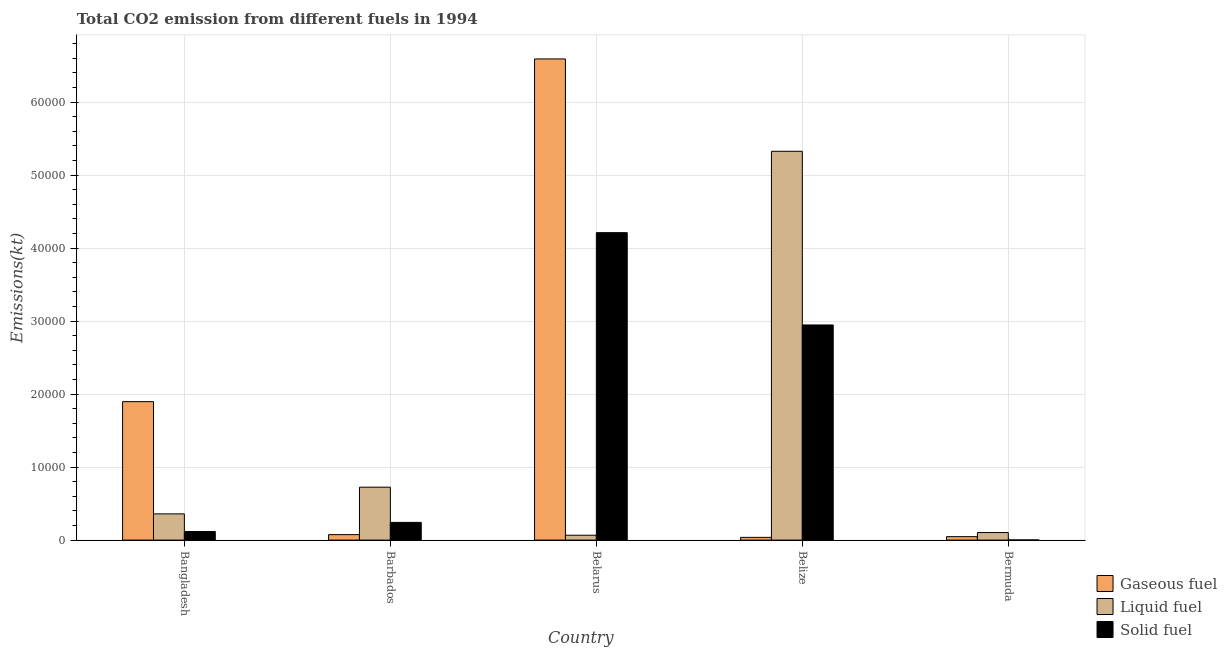How many groups of bars are there?
Provide a succinct answer. 5. Are the number of bars on each tick of the X-axis equal?
Ensure brevity in your answer.  Yes. How many bars are there on the 3rd tick from the right?
Keep it short and to the point. 3. What is the label of the 1st group of bars from the left?
Provide a succinct answer. Bangladesh. What is the amount of co2 emissions from liquid fuel in Barbados?
Give a very brief answer. 7249.66. Across all countries, what is the maximum amount of co2 emissions from solid fuel?
Your response must be concise. 4.21e+04. Across all countries, what is the minimum amount of co2 emissions from liquid fuel?
Make the answer very short. 667.39. In which country was the amount of co2 emissions from gaseous fuel maximum?
Your answer should be very brief. Belarus. In which country was the amount of co2 emissions from solid fuel minimum?
Give a very brief answer. Bermuda. What is the total amount of co2 emissions from gaseous fuel in the graph?
Provide a short and direct response. 8.65e+04. What is the difference between the amount of co2 emissions from solid fuel in Belarus and that in Bermuda?
Provide a short and direct response. 4.21e+04. What is the difference between the amount of co2 emissions from liquid fuel in Bermuda and the amount of co2 emissions from gaseous fuel in Barbados?
Keep it short and to the point. 286.03. What is the average amount of co2 emissions from liquid fuel per country?
Your answer should be compact. 1.32e+04. What is the difference between the amount of co2 emissions from liquid fuel and amount of co2 emissions from gaseous fuel in Bermuda?
Make the answer very short. 561.05. In how many countries, is the amount of co2 emissions from solid fuel greater than 66000 kt?
Give a very brief answer. 0. What is the ratio of the amount of co2 emissions from liquid fuel in Barbados to that in Belize?
Your answer should be very brief. 0.14. Is the difference between the amount of co2 emissions from solid fuel in Bangladesh and Belize greater than the difference between the amount of co2 emissions from gaseous fuel in Bangladesh and Belize?
Provide a short and direct response. No. What is the difference between the highest and the second highest amount of co2 emissions from solid fuel?
Ensure brevity in your answer.  1.26e+04. What is the difference between the highest and the lowest amount of co2 emissions from gaseous fuel?
Offer a terse response. 6.55e+04. Is the sum of the amount of co2 emissions from gaseous fuel in Bangladesh and Belize greater than the maximum amount of co2 emissions from solid fuel across all countries?
Ensure brevity in your answer.  No. What does the 2nd bar from the left in Belize represents?
Give a very brief answer. Liquid fuel. What does the 1st bar from the right in Belarus represents?
Offer a terse response. Solid fuel. Is it the case that in every country, the sum of the amount of co2 emissions from gaseous fuel and amount of co2 emissions from liquid fuel is greater than the amount of co2 emissions from solid fuel?
Offer a terse response. Yes. Are all the bars in the graph horizontal?
Provide a succinct answer. No. How many countries are there in the graph?
Your answer should be very brief. 5. Does the graph contain any zero values?
Your answer should be compact. No. Does the graph contain grids?
Provide a succinct answer. Yes. Where does the legend appear in the graph?
Provide a short and direct response. Bottom right. How are the legend labels stacked?
Offer a terse response. Vertical. What is the title of the graph?
Your response must be concise. Total CO2 emission from different fuels in 1994. Does "Ores and metals" appear as one of the legend labels in the graph?
Offer a very short reply. No. What is the label or title of the X-axis?
Your answer should be very brief. Country. What is the label or title of the Y-axis?
Provide a succinct answer. Emissions(kt). What is the Emissions(kt) in Gaseous fuel in Bangladesh?
Your answer should be very brief. 1.90e+04. What is the Emissions(kt) of Liquid fuel in Bangladesh?
Your answer should be very brief. 3593.66. What is the Emissions(kt) of Solid fuel in Bangladesh?
Provide a short and direct response. 1177.11. What is the Emissions(kt) in Gaseous fuel in Barbados?
Your answer should be very brief. 748.07. What is the Emissions(kt) of Liquid fuel in Barbados?
Your answer should be very brief. 7249.66. What is the Emissions(kt) in Solid fuel in Barbados?
Keep it short and to the point. 2427.55. What is the Emissions(kt) in Gaseous fuel in Belarus?
Offer a terse response. 6.59e+04. What is the Emissions(kt) of Liquid fuel in Belarus?
Offer a terse response. 667.39. What is the Emissions(kt) in Solid fuel in Belarus?
Your answer should be very brief. 4.21e+04. What is the Emissions(kt) in Gaseous fuel in Belize?
Provide a short and direct response. 374.03. What is the Emissions(kt) of Liquid fuel in Belize?
Your response must be concise. 5.33e+04. What is the Emissions(kt) in Solid fuel in Belize?
Your answer should be very brief. 2.95e+04. What is the Emissions(kt) in Gaseous fuel in Bermuda?
Ensure brevity in your answer.  473.04. What is the Emissions(kt) of Liquid fuel in Bermuda?
Offer a terse response. 1034.09. What is the Emissions(kt) in Solid fuel in Bermuda?
Offer a terse response. 18.34. Across all countries, what is the maximum Emissions(kt) in Gaseous fuel?
Provide a short and direct response. 6.59e+04. Across all countries, what is the maximum Emissions(kt) of Liquid fuel?
Your answer should be compact. 5.33e+04. Across all countries, what is the maximum Emissions(kt) in Solid fuel?
Your response must be concise. 4.21e+04. Across all countries, what is the minimum Emissions(kt) in Gaseous fuel?
Offer a terse response. 374.03. Across all countries, what is the minimum Emissions(kt) in Liquid fuel?
Your response must be concise. 667.39. Across all countries, what is the minimum Emissions(kt) in Solid fuel?
Provide a succinct answer. 18.34. What is the total Emissions(kt) in Gaseous fuel in the graph?
Give a very brief answer. 8.65e+04. What is the total Emissions(kt) of Liquid fuel in the graph?
Offer a terse response. 6.58e+04. What is the total Emissions(kt) of Solid fuel in the graph?
Offer a terse response. 7.52e+04. What is the difference between the Emissions(kt) in Gaseous fuel in Bangladesh and that in Barbados?
Your answer should be compact. 1.82e+04. What is the difference between the Emissions(kt) in Liquid fuel in Bangladesh and that in Barbados?
Keep it short and to the point. -3656. What is the difference between the Emissions(kt) of Solid fuel in Bangladesh and that in Barbados?
Provide a short and direct response. -1250.45. What is the difference between the Emissions(kt) in Gaseous fuel in Bangladesh and that in Belarus?
Provide a short and direct response. -4.69e+04. What is the difference between the Emissions(kt) in Liquid fuel in Bangladesh and that in Belarus?
Provide a short and direct response. 2926.27. What is the difference between the Emissions(kt) in Solid fuel in Bangladesh and that in Belarus?
Keep it short and to the point. -4.09e+04. What is the difference between the Emissions(kt) in Gaseous fuel in Bangladesh and that in Belize?
Provide a short and direct response. 1.86e+04. What is the difference between the Emissions(kt) of Liquid fuel in Bangladesh and that in Belize?
Your answer should be very brief. -4.97e+04. What is the difference between the Emissions(kt) in Solid fuel in Bangladesh and that in Belize?
Give a very brief answer. -2.83e+04. What is the difference between the Emissions(kt) of Gaseous fuel in Bangladesh and that in Bermuda?
Your answer should be very brief. 1.85e+04. What is the difference between the Emissions(kt) of Liquid fuel in Bangladesh and that in Bermuda?
Offer a very short reply. 2559.57. What is the difference between the Emissions(kt) of Solid fuel in Bangladesh and that in Bermuda?
Your answer should be compact. 1158.77. What is the difference between the Emissions(kt) of Gaseous fuel in Barbados and that in Belarus?
Give a very brief answer. -6.52e+04. What is the difference between the Emissions(kt) in Liquid fuel in Barbados and that in Belarus?
Your answer should be compact. 6582.27. What is the difference between the Emissions(kt) in Solid fuel in Barbados and that in Belarus?
Keep it short and to the point. -3.97e+04. What is the difference between the Emissions(kt) in Gaseous fuel in Barbados and that in Belize?
Keep it short and to the point. 374.03. What is the difference between the Emissions(kt) of Liquid fuel in Barbados and that in Belize?
Your answer should be very brief. -4.60e+04. What is the difference between the Emissions(kt) of Solid fuel in Barbados and that in Belize?
Your answer should be very brief. -2.70e+04. What is the difference between the Emissions(kt) in Gaseous fuel in Barbados and that in Bermuda?
Provide a short and direct response. 275.02. What is the difference between the Emissions(kt) of Liquid fuel in Barbados and that in Bermuda?
Offer a terse response. 6215.56. What is the difference between the Emissions(kt) in Solid fuel in Barbados and that in Bermuda?
Your response must be concise. 2409.22. What is the difference between the Emissions(kt) of Gaseous fuel in Belarus and that in Belize?
Provide a short and direct response. 6.55e+04. What is the difference between the Emissions(kt) in Liquid fuel in Belarus and that in Belize?
Keep it short and to the point. -5.26e+04. What is the difference between the Emissions(kt) of Solid fuel in Belarus and that in Belize?
Keep it short and to the point. 1.26e+04. What is the difference between the Emissions(kt) of Gaseous fuel in Belarus and that in Bermuda?
Your response must be concise. 6.54e+04. What is the difference between the Emissions(kt) in Liquid fuel in Belarus and that in Bermuda?
Provide a succinct answer. -366.7. What is the difference between the Emissions(kt) in Solid fuel in Belarus and that in Bermuda?
Provide a short and direct response. 4.21e+04. What is the difference between the Emissions(kt) of Gaseous fuel in Belize and that in Bermuda?
Offer a terse response. -99.01. What is the difference between the Emissions(kt) in Liquid fuel in Belize and that in Bermuda?
Ensure brevity in your answer.  5.22e+04. What is the difference between the Emissions(kt) of Solid fuel in Belize and that in Bermuda?
Provide a succinct answer. 2.95e+04. What is the difference between the Emissions(kt) in Gaseous fuel in Bangladesh and the Emissions(kt) in Liquid fuel in Barbados?
Your answer should be very brief. 1.17e+04. What is the difference between the Emissions(kt) of Gaseous fuel in Bangladesh and the Emissions(kt) of Solid fuel in Barbados?
Your response must be concise. 1.65e+04. What is the difference between the Emissions(kt) of Liquid fuel in Bangladesh and the Emissions(kt) of Solid fuel in Barbados?
Offer a very short reply. 1166.11. What is the difference between the Emissions(kt) in Gaseous fuel in Bangladesh and the Emissions(kt) in Liquid fuel in Belarus?
Make the answer very short. 1.83e+04. What is the difference between the Emissions(kt) of Gaseous fuel in Bangladesh and the Emissions(kt) of Solid fuel in Belarus?
Make the answer very short. -2.31e+04. What is the difference between the Emissions(kt) of Liquid fuel in Bangladesh and the Emissions(kt) of Solid fuel in Belarus?
Keep it short and to the point. -3.85e+04. What is the difference between the Emissions(kt) of Gaseous fuel in Bangladesh and the Emissions(kt) of Liquid fuel in Belize?
Offer a terse response. -3.43e+04. What is the difference between the Emissions(kt) of Gaseous fuel in Bangladesh and the Emissions(kt) of Solid fuel in Belize?
Give a very brief answer. -1.05e+04. What is the difference between the Emissions(kt) in Liquid fuel in Bangladesh and the Emissions(kt) in Solid fuel in Belize?
Your answer should be compact. -2.59e+04. What is the difference between the Emissions(kt) in Gaseous fuel in Bangladesh and the Emissions(kt) in Liquid fuel in Bermuda?
Your response must be concise. 1.79e+04. What is the difference between the Emissions(kt) in Gaseous fuel in Bangladesh and the Emissions(kt) in Solid fuel in Bermuda?
Your answer should be compact. 1.90e+04. What is the difference between the Emissions(kt) of Liquid fuel in Bangladesh and the Emissions(kt) of Solid fuel in Bermuda?
Make the answer very short. 3575.32. What is the difference between the Emissions(kt) of Gaseous fuel in Barbados and the Emissions(kt) of Liquid fuel in Belarus?
Provide a short and direct response. 80.67. What is the difference between the Emissions(kt) of Gaseous fuel in Barbados and the Emissions(kt) of Solid fuel in Belarus?
Your answer should be very brief. -4.14e+04. What is the difference between the Emissions(kt) in Liquid fuel in Barbados and the Emissions(kt) in Solid fuel in Belarus?
Your response must be concise. -3.49e+04. What is the difference between the Emissions(kt) in Gaseous fuel in Barbados and the Emissions(kt) in Liquid fuel in Belize?
Offer a very short reply. -5.25e+04. What is the difference between the Emissions(kt) of Gaseous fuel in Barbados and the Emissions(kt) of Solid fuel in Belize?
Keep it short and to the point. -2.87e+04. What is the difference between the Emissions(kt) in Liquid fuel in Barbados and the Emissions(kt) in Solid fuel in Belize?
Your answer should be compact. -2.22e+04. What is the difference between the Emissions(kt) of Gaseous fuel in Barbados and the Emissions(kt) of Liquid fuel in Bermuda?
Your answer should be very brief. -286.03. What is the difference between the Emissions(kt) of Gaseous fuel in Barbados and the Emissions(kt) of Solid fuel in Bermuda?
Offer a terse response. 729.73. What is the difference between the Emissions(kt) in Liquid fuel in Barbados and the Emissions(kt) in Solid fuel in Bermuda?
Ensure brevity in your answer.  7231.32. What is the difference between the Emissions(kt) in Gaseous fuel in Belarus and the Emissions(kt) in Liquid fuel in Belize?
Offer a terse response. 1.27e+04. What is the difference between the Emissions(kt) of Gaseous fuel in Belarus and the Emissions(kt) of Solid fuel in Belize?
Your response must be concise. 3.64e+04. What is the difference between the Emissions(kt) in Liquid fuel in Belarus and the Emissions(kt) in Solid fuel in Belize?
Provide a succinct answer. -2.88e+04. What is the difference between the Emissions(kt) of Gaseous fuel in Belarus and the Emissions(kt) of Liquid fuel in Bermuda?
Your response must be concise. 6.49e+04. What is the difference between the Emissions(kt) in Gaseous fuel in Belarus and the Emissions(kt) in Solid fuel in Bermuda?
Ensure brevity in your answer.  6.59e+04. What is the difference between the Emissions(kt) of Liquid fuel in Belarus and the Emissions(kt) of Solid fuel in Bermuda?
Your answer should be compact. 649.06. What is the difference between the Emissions(kt) in Gaseous fuel in Belize and the Emissions(kt) in Liquid fuel in Bermuda?
Ensure brevity in your answer.  -660.06. What is the difference between the Emissions(kt) of Gaseous fuel in Belize and the Emissions(kt) of Solid fuel in Bermuda?
Your response must be concise. 355.7. What is the difference between the Emissions(kt) in Liquid fuel in Belize and the Emissions(kt) in Solid fuel in Bermuda?
Give a very brief answer. 5.32e+04. What is the average Emissions(kt) in Gaseous fuel per country?
Your response must be concise. 1.73e+04. What is the average Emissions(kt) of Liquid fuel per country?
Provide a succinct answer. 1.32e+04. What is the average Emissions(kt) of Solid fuel per country?
Provide a succinct answer. 1.50e+04. What is the difference between the Emissions(kt) in Gaseous fuel and Emissions(kt) in Liquid fuel in Bangladesh?
Your answer should be compact. 1.54e+04. What is the difference between the Emissions(kt) in Gaseous fuel and Emissions(kt) in Solid fuel in Bangladesh?
Your answer should be very brief. 1.78e+04. What is the difference between the Emissions(kt) of Liquid fuel and Emissions(kt) of Solid fuel in Bangladesh?
Keep it short and to the point. 2416.55. What is the difference between the Emissions(kt) in Gaseous fuel and Emissions(kt) in Liquid fuel in Barbados?
Your response must be concise. -6501.59. What is the difference between the Emissions(kt) of Gaseous fuel and Emissions(kt) of Solid fuel in Barbados?
Offer a very short reply. -1679.49. What is the difference between the Emissions(kt) of Liquid fuel and Emissions(kt) of Solid fuel in Barbados?
Offer a terse response. 4822.1. What is the difference between the Emissions(kt) in Gaseous fuel and Emissions(kt) in Liquid fuel in Belarus?
Provide a succinct answer. 6.52e+04. What is the difference between the Emissions(kt) of Gaseous fuel and Emissions(kt) of Solid fuel in Belarus?
Give a very brief answer. 2.38e+04. What is the difference between the Emissions(kt) of Liquid fuel and Emissions(kt) of Solid fuel in Belarus?
Give a very brief answer. -4.14e+04. What is the difference between the Emissions(kt) of Gaseous fuel and Emissions(kt) of Liquid fuel in Belize?
Your answer should be compact. -5.29e+04. What is the difference between the Emissions(kt) of Gaseous fuel and Emissions(kt) of Solid fuel in Belize?
Give a very brief answer. -2.91e+04. What is the difference between the Emissions(kt) of Liquid fuel and Emissions(kt) of Solid fuel in Belize?
Your answer should be very brief. 2.38e+04. What is the difference between the Emissions(kt) in Gaseous fuel and Emissions(kt) in Liquid fuel in Bermuda?
Provide a succinct answer. -561.05. What is the difference between the Emissions(kt) in Gaseous fuel and Emissions(kt) in Solid fuel in Bermuda?
Ensure brevity in your answer.  454.71. What is the difference between the Emissions(kt) in Liquid fuel and Emissions(kt) in Solid fuel in Bermuda?
Keep it short and to the point. 1015.76. What is the ratio of the Emissions(kt) in Gaseous fuel in Bangladesh to that in Barbados?
Offer a terse response. 25.36. What is the ratio of the Emissions(kt) in Liquid fuel in Bangladesh to that in Barbados?
Ensure brevity in your answer.  0.5. What is the ratio of the Emissions(kt) in Solid fuel in Bangladesh to that in Barbados?
Your answer should be compact. 0.48. What is the ratio of the Emissions(kt) in Gaseous fuel in Bangladesh to that in Belarus?
Ensure brevity in your answer.  0.29. What is the ratio of the Emissions(kt) in Liquid fuel in Bangladesh to that in Belarus?
Give a very brief answer. 5.38. What is the ratio of the Emissions(kt) of Solid fuel in Bangladesh to that in Belarus?
Your answer should be compact. 0.03. What is the ratio of the Emissions(kt) in Gaseous fuel in Bangladesh to that in Belize?
Offer a terse response. 50.72. What is the ratio of the Emissions(kt) in Liquid fuel in Bangladesh to that in Belize?
Your answer should be compact. 0.07. What is the ratio of the Emissions(kt) in Solid fuel in Bangladesh to that in Belize?
Your answer should be very brief. 0.04. What is the ratio of the Emissions(kt) of Gaseous fuel in Bangladesh to that in Bermuda?
Make the answer very short. 40.1. What is the ratio of the Emissions(kt) in Liquid fuel in Bangladesh to that in Bermuda?
Offer a very short reply. 3.48. What is the ratio of the Emissions(kt) of Solid fuel in Bangladesh to that in Bermuda?
Offer a very short reply. 64.2. What is the ratio of the Emissions(kt) of Gaseous fuel in Barbados to that in Belarus?
Offer a terse response. 0.01. What is the ratio of the Emissions(kt) in Liquid fuel in Barbados to that in Belarus?
Ensure brevity in your answer.  10.86. What is the ratio of the Emissions(kt) of Solid fuel in Barbados to that in Belarus?
Provide a short and direct response. 0.06. What is the ratio of the Emissions(kt) of Gaseous fuel in Barbados to that in Belize?
Make the answer very short. 2. What is the ratio of the Emissions(kt) of Liquid fuel in Barbados to that in Belize?
Offer a very short reply. 0.14. What is the ratio of the Emissions(kt) of Solid fuel in Barbados to that in Belize?
Your answer should be very brief. 0.08. What is the ratio of the Emissions(kt) in Gaseous fuel in Barbados to that in Bermuda?
Provide a short and direct response. 1.58. What is the ratio of the Emissions(kt) of Liquid fuel in Barbados to that in Bermuda?
Keep it short and to the point. 7.01. What is the ratio of the Emissions(kt) of Solid fuel in Barbados to that in Bermuda?
Provide a short and direct response. 132.4. What is the ratio of the Emissions(kt) of Gaseous fuel in Belarus to that in Belize?
Provide a succinct answer. 176.23. What is the ratio of the Emissions(kt) of Liquid fuel in Belarus to that in Belize?
Your response must be concise. 0.01. What is the ratio of the Emissions(kt) of Solid fuel in Belarus to that in Belize?
Offer a very short reply. 1.43. What is the ratio of the Emissions(kt) in Gaseous fuel in Belarus to that in Bermuda?
Your answer should be very brief. 139.34. What is the ratio of the Emissions(kt) in Liquid fuel in Belarus to that in Bermuda?
Provide a succinct answer. 0.65. What is the ratio of the Emissions(kt) in Solid fuel in Belarus to that in Bermuda?
Make the answer very short. 2297. What is the ratio of the Emissions(kt) of Gaseous fuel in Belize to that in Bermuda?
Your response must be concise. 0.79. What is the ratio of the Emissions(kt) of Liquid fuel in Belize to that in Bermuda?
Ensure brevity in your answer.  51.51. What is the ratio of the Emissions(kt) of Solid fuel in Belize to that in Bermuda?
Provide a short and direct response. 1607.4. What is the difference between the highest and the second highest Emissions(kt) of Gaseous fuel?
Your answer should be compact. 4.69e+04. What is the difference between the highest and the second highest Emissions(kt) of Liquid fuel?
Make the answer very short. 4.60e+04. What is the difference between the highest and the second highest Emissions(kt) of Solid fuel?
Provide a short and direct response. 1.26e+04. What is the difference between the highest and the lowest Emissions(kt) of Gaseous fuel?
Ensure brevity in your answer.  6.55e+04. What is the difference between the highest and the lowest Emissions(kt) of Liquid fuel?
Your response must be concise. 5.26e+04. What is the difference between the highest and the lowest Emissions(kt) in Solid fuel?
Offer a terse response. 4.21e+04. 